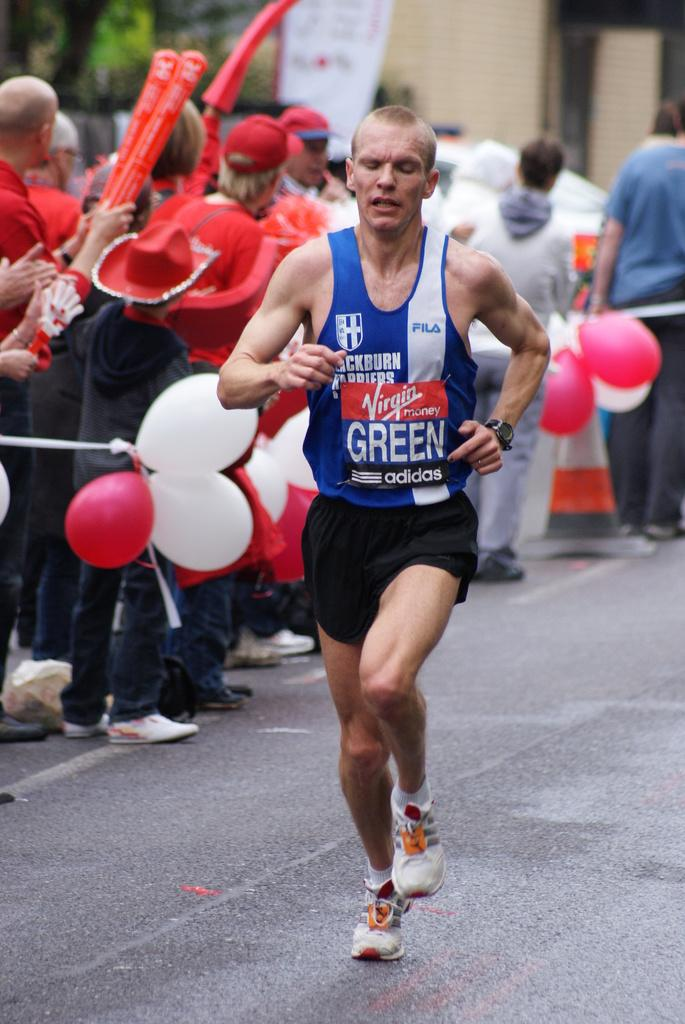<image>
Give a short and clear explanation of the subsequent image. A marathon player run in the track whose jersey has lettering as Virgin money ,green ,adidas 